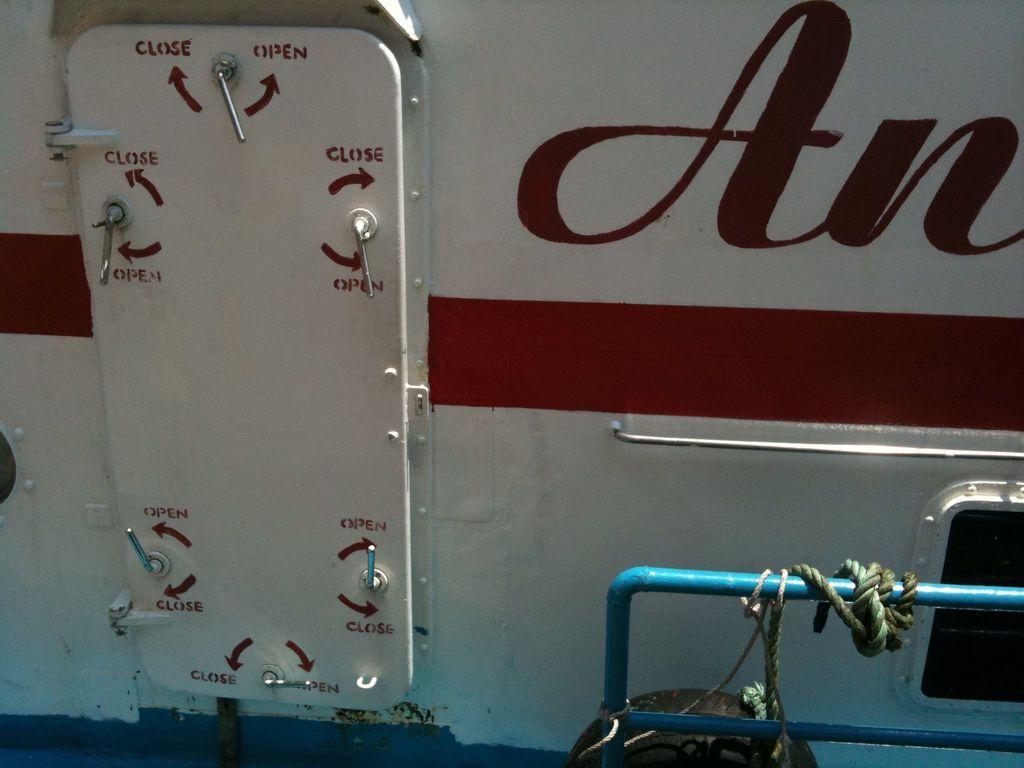Can you describe this image briefly? Bottom right side of the image there is a fencing, on the fencing there is a rope. Behind the fencing there is a vehicle. 